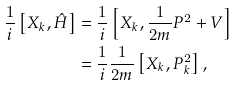<formula> <loc_0><loc_0><loc_500><loc_500>\frac { 1 } { i } \left [ X _ { k } , \hat { H } \right ] & = \frac { 1 } { i } \left [ X _ { k } , \frac { 1 } { 2 m } P ^ { 2 } + V \right ] \\ & = \frac { 1 } { i } \frac { 1 } { 2 m } \left [ X _ { k } , P _ { k } ^ { 2 } \right ] ,</formula> 